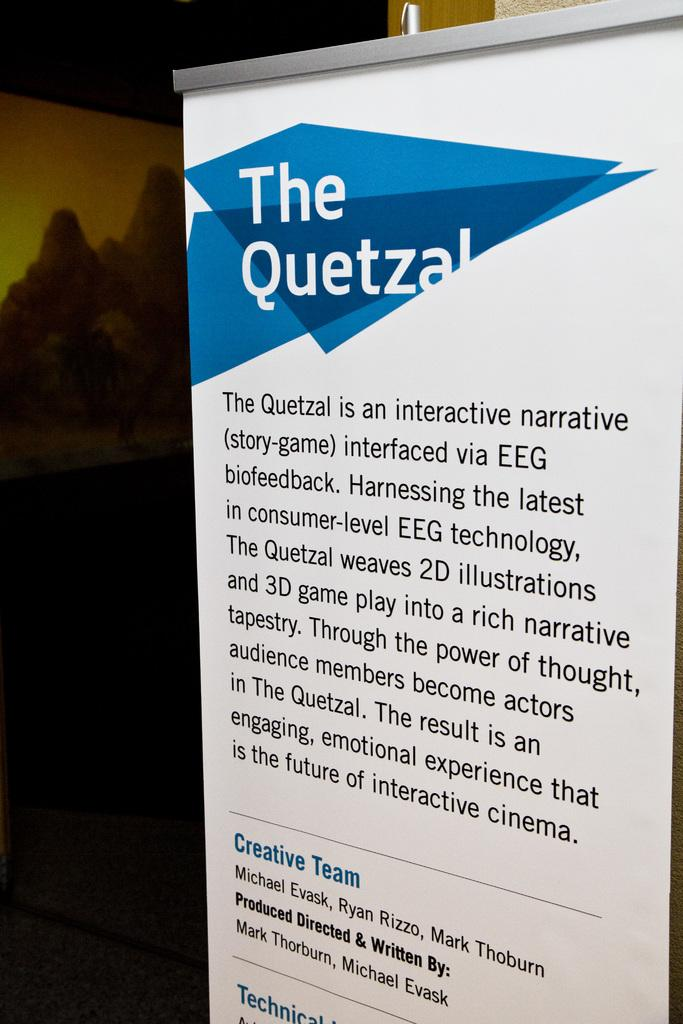<image>
Present a compact description of the photo's key features. A large sign that has "The Quetzal" printed on it. 